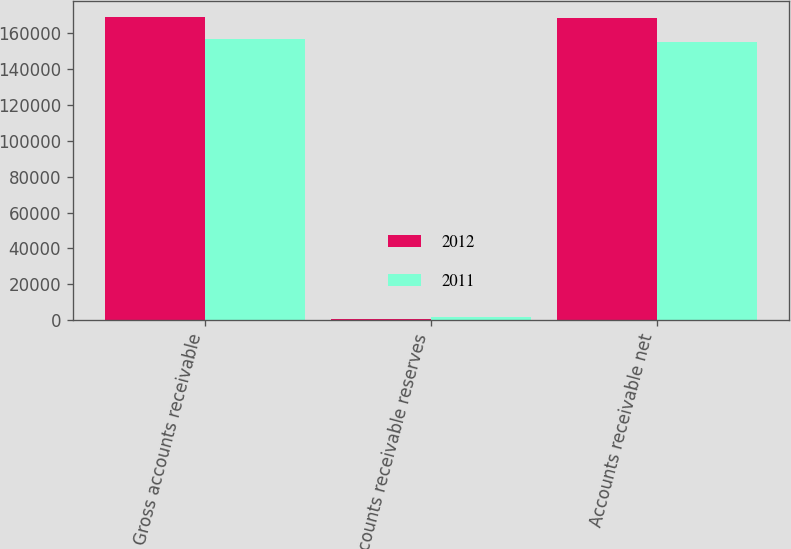Convert chart to OTSL. <chart><loc_0><loc_0><loc_500><loc_500><stacked_bar_chart><ecel><fcel>Gross accounts receivable<fcel>Accounts receivable reserves<fcel>Accounts receivable net<nl><fcel>2012<fcel>169401<fcel>669<fcel>168732<nl><fcel>2011<fcel>156790<fcel>1560<fcel>155230<nl></chart> 